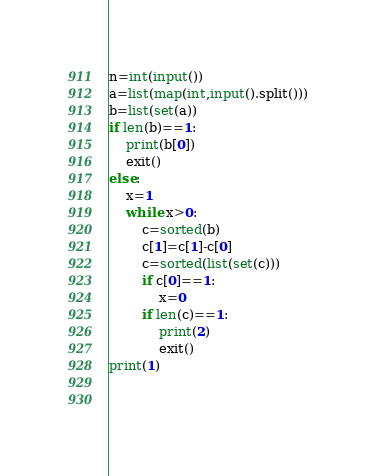<code> <loc_0><loc_0><loc_500><loc_500><_Python_>n=int(input())
a=list(map(int,input().split()))
b=list(set(a))   
if len(b)==1:
    print(b[0])
    exit()
else: 
    x=1
    while x>0:
        c=sorted(b)
        c[1]=c[1]-c[0]
        c=sorted(list(set(c)))
        if c[0]==1:
            x=0
        if len(c)==1:
            print(2)
            exit()
print(1)
            
    


</code> 